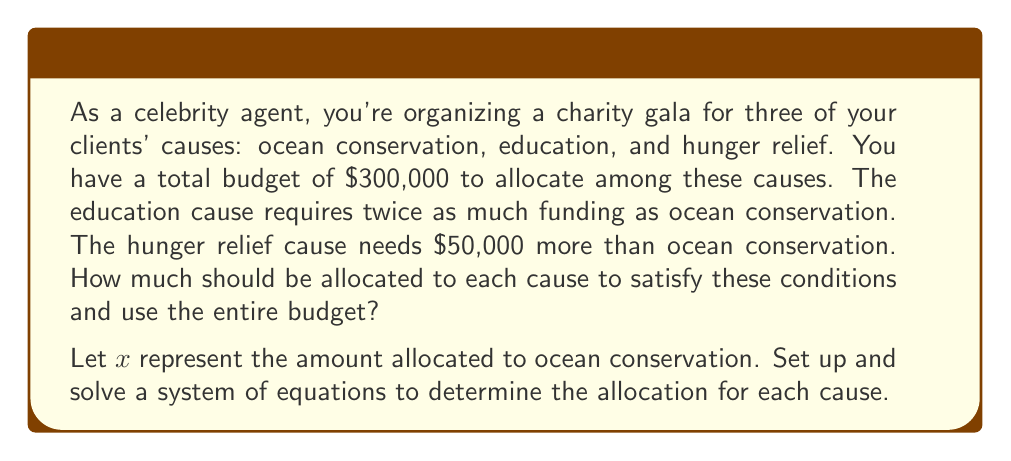Show me your answer to this math problem. Let's define our variables:
$x$ = amount allocated to ocean conservation
$2x$ = amount allocated to education (twice as much as ocean conservation)
$x + 50,000$ = amount allocated to hunger relief ($50,000 more than ocean conservation)

Now, we can set up our system of equations:

1) The sum of all allocations must equal the total budget:
   $$x + 2x + (x + 50,000) = 300,000$$

2) Simplify the equation:
   $$4x + 50,000 = 300,000$$

3) Subtract 50,000 from both sides:
   $$4x = 250,000$$

4) Divide both sides by 4:
   $$x = 62,500$$

Now that we know $x$, we can calculate the other allocations:

5) Education: $2x = 2(62,500) = 125,000$

6) Hunger relief: $x + 50,000 = 62,500 + 50,000 = 112,500$

7) Verify the total:
   $$62,500 + 125,000 + 112,500 = 300,000$$

The allocations satisfy all conditions and use the entire budget.
Answer: Ocean conservation: $62,500
Education: $125,000
Hunger relief: $112,500 